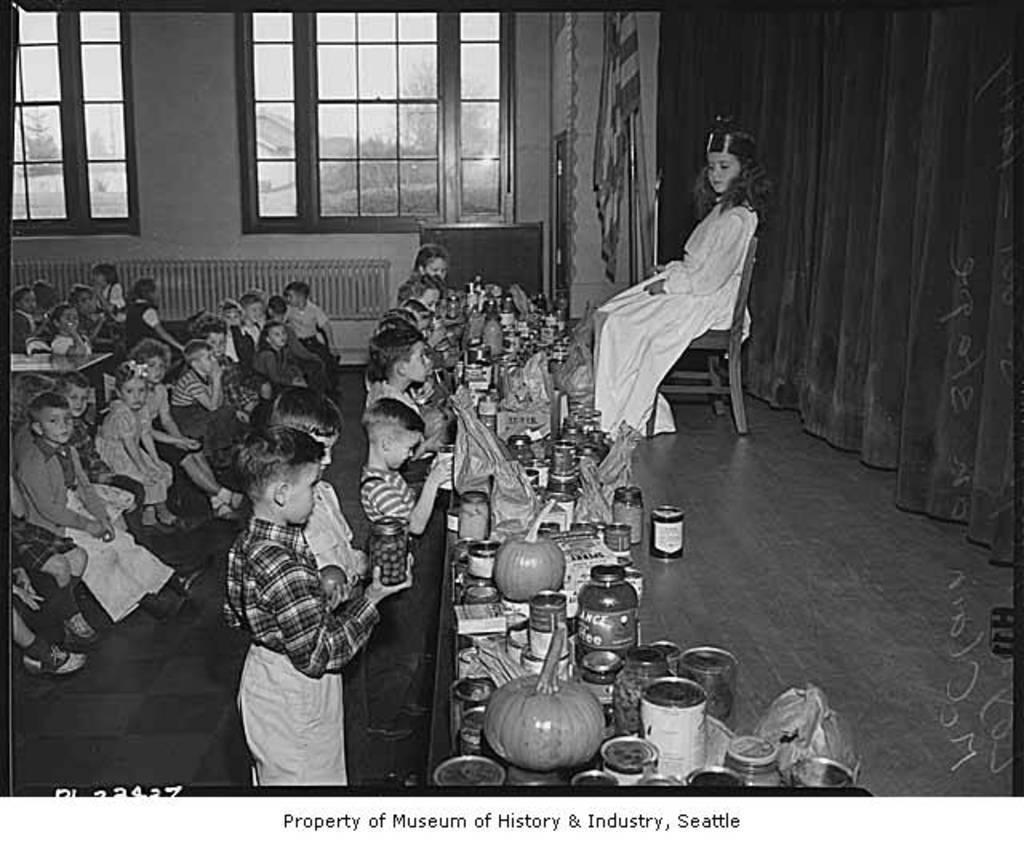How would you summarize this image in a sentence or two? In this black and white image, we can see some kids in front of the table. This table contains pumpkins, bottles and containers. There is an another kid in the middle of the image sitting on the chair. There are curtains in the top right of the image. There is a flag at the top of the image. There are windows in the top left of the image. There is a text at the bottom of the image. 